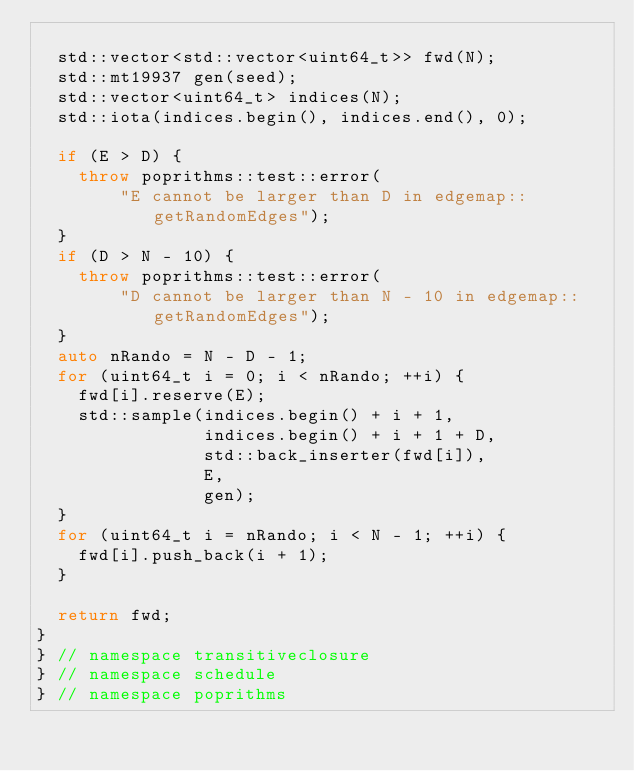Convert code to text. <code><loc_0><loc_0><loc_500><loc_500><_C++_>
  std::vector<std::vector<uint64_t>> fwd(N);
  std::mt19937 gen(seed);
  std::vector<uint64_t> indices(N);
  std::iota(indices.begin(), indices.end(), 0);

  if (E > D) {
    throw poprithms::test::error(
        "E cannot be larger than D in edgemap::getRandomEdges");
  }
  if (D > N - 10) {
    throw poprithms::test::error(
        "D cannot be larger than N - 10 in edgemap::getRandomEdges");
  }
  auto nRando = N - D - 1;
  for (uint64_t i = 0; i < nRando; ++i) {
    fwd[i].reserve(E);
    std::sample(indices.begin() + i + 1,
                indices.begin() + i + 1 + D,
                std::back_inserter(fwd[i]),
                E,
                gen);
  }
  for (uint64_t i = nRando; i < N - 1; ++i) {
    fwd[i].push_back(i + 1);
  }

  return fwd;
}
} // namespace transitiveclosure
} // namespace schedule
} // namespace poprithms
</code> 